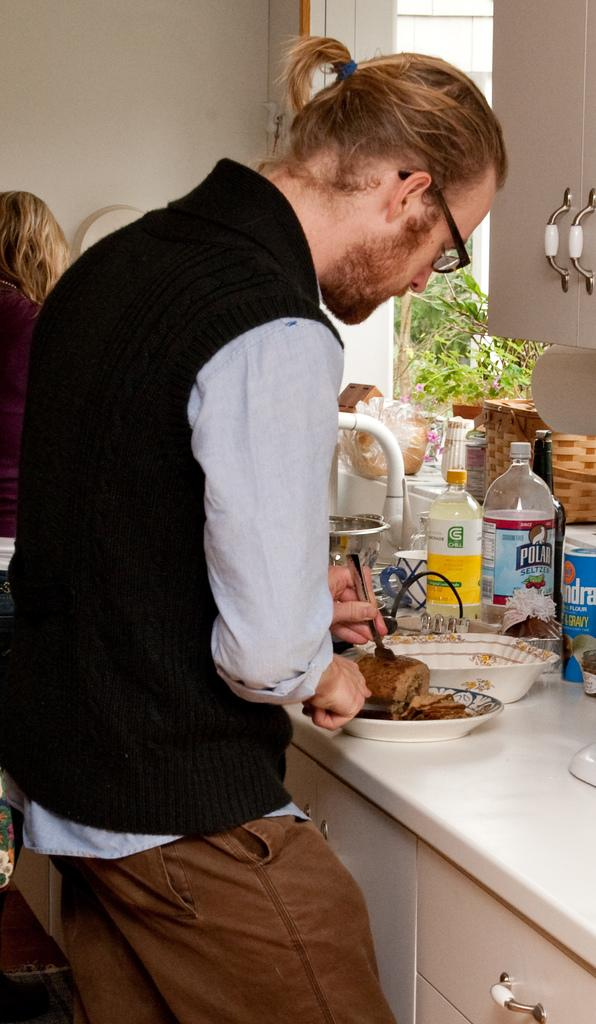<image>
Relay a brief, clear account of the picture shown. A man slicing food in front of a polar seltzer water 